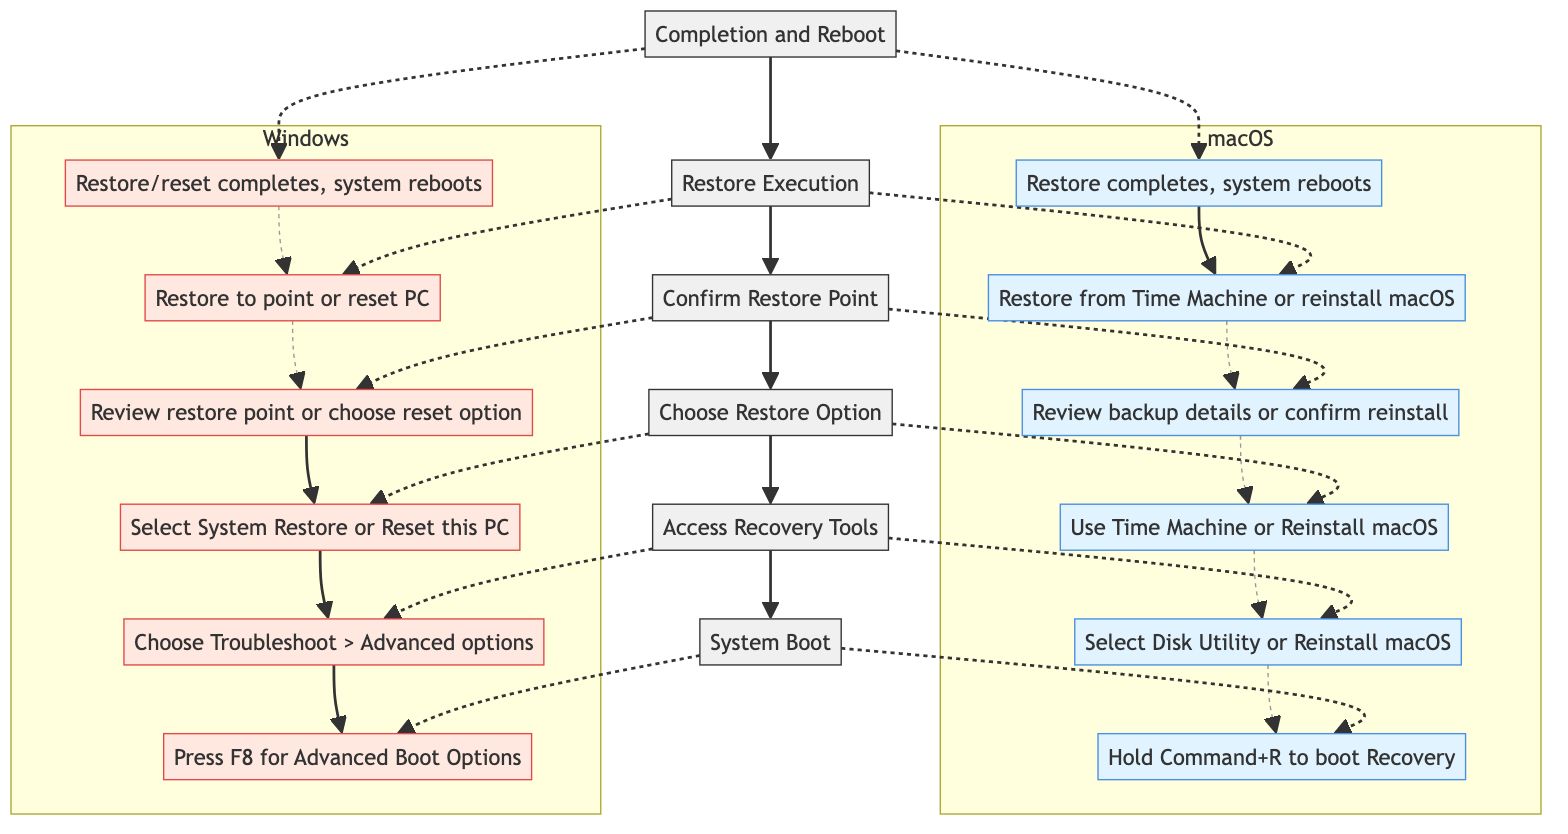What's the final step in the system restore process? The diagram shows that the final step is labeled "Completion and Reboot," which indicates that the process concludes with a system reboot into the restored state.
Answer: Completion and Reboot What is the first action to take for macOS system boot? The diagram specifies that for macOS, you should "Hold Command+R to boot Recovery" as the first action during the system boot process.
Answer: Hold Command+R to boot Recovery How many steps are in the flowchart? The flowchart lists a total of six steps that outline the system restore process for both macOS and Windows.
Answer: 6 Which step involves confirming the restore point? According to the diagram, the step labeled "Confirm Restore Point" is where the system checks and confirms the selected restore point before proceeding.
Answer: Confirm Restore Point What tool does macOS recommend for restoring from a backup? The diagram indicates that macOS recommends using "Time Machine" to restore from a previous backup during the restoration process.
Answer: Time Machine What action is taken in the "Restore Execution" step on Windows? The flowchart states that in the "Restore Execution" step, Windows will either restore to the selected restore point or reset the PC based on the chosen option.
Answer: Restore to the selected restore point or reset the PC How does the Windows system boot differ from macOS? The diagram shows that macOS uses "Hold Command+R" to boot into Recovery, while Windows instructs the user to "Press F8 for Advanced Boot Options," indicating a different method for accessing recovery tools.
Answer: Press F8 for Advanced Boot Options What does the "Choose Restore Option" step involve for macOS? The flowchart reveals that in this step for macOS, the user selects either "Use Time Machine to restore from a previous backup or select 'Reinstall macOS'."
Answer: Use Time Machine or Reinstall macOS In which step do users access system recovery tools on Windows? The diagram shows that users access system recovery tools in the step labeled "Access Recovery Tools" after the initial boot sequence.
Answer: Access Recovery Tools 